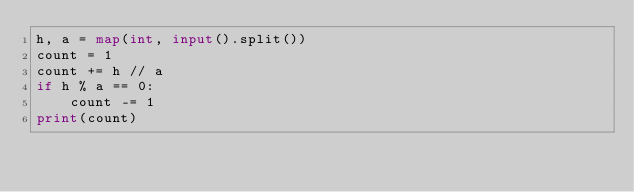<code> <loc_0><loc_0><loc_500><loc_500><_Python_>h, a = map(int, input().split())
count = 1
count += h // a
if h % a == 0:
    count -= 1
print(count)</code> 